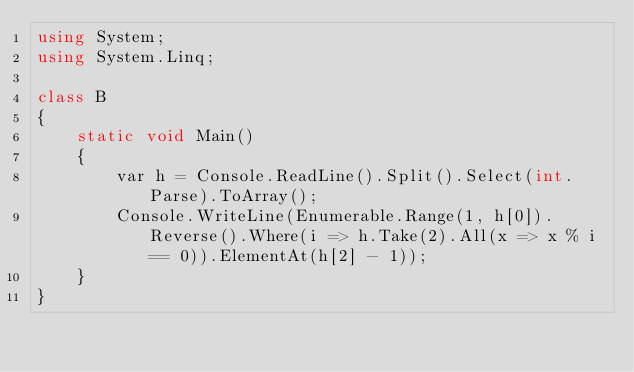<code> <loc_0><loc_0><loc_500><loc_500><_C#_>using System;
using System.Linq;

class B
{
	static void Main()
	{
		var h = Console.ReadLine().Split().Select(int.Parse).ToArray();
		Console.WriteLine(Enumerable.Range(1, h[0]).Reverse().Where(i => h.Take(2).All(x => x % i == 0)).ElementAt(h[2] - 1));
	}
}
</code> 